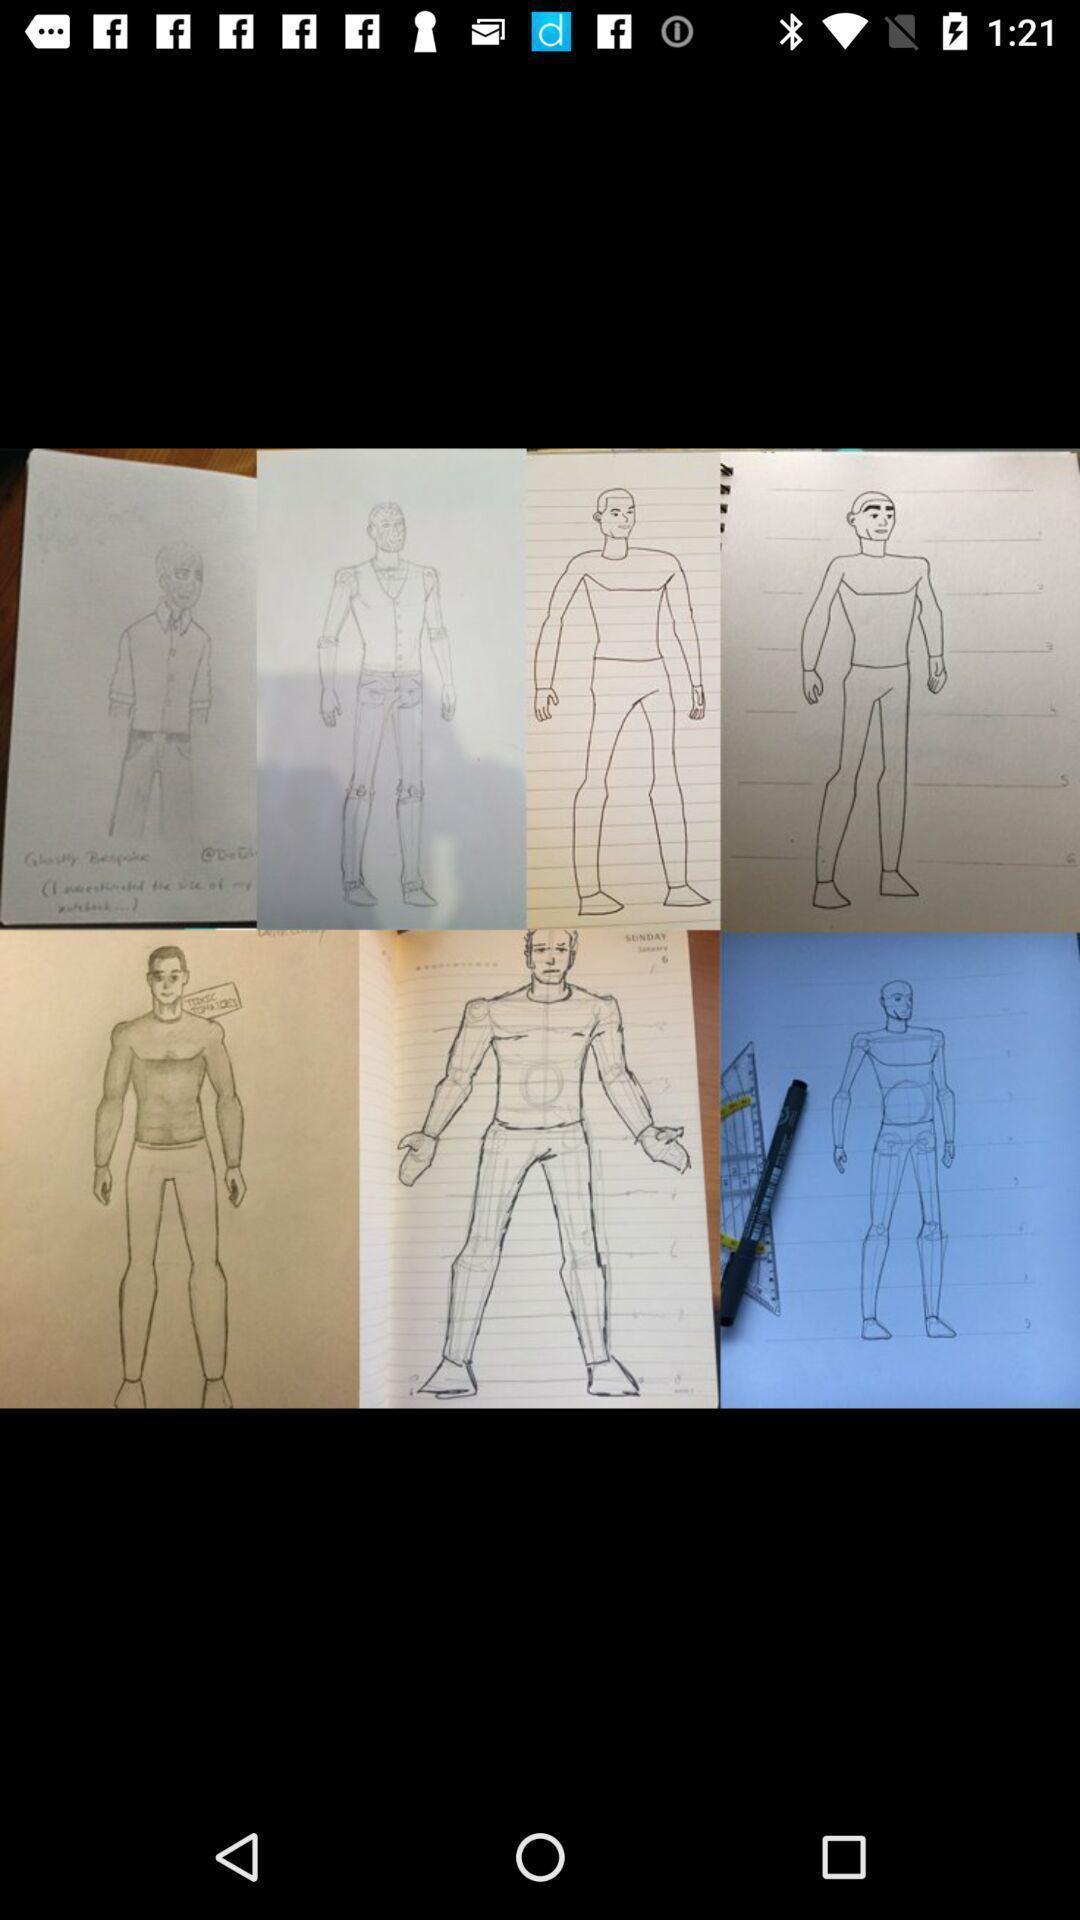Describe the visual elements of this screenshot. Screen showing various animated images. 